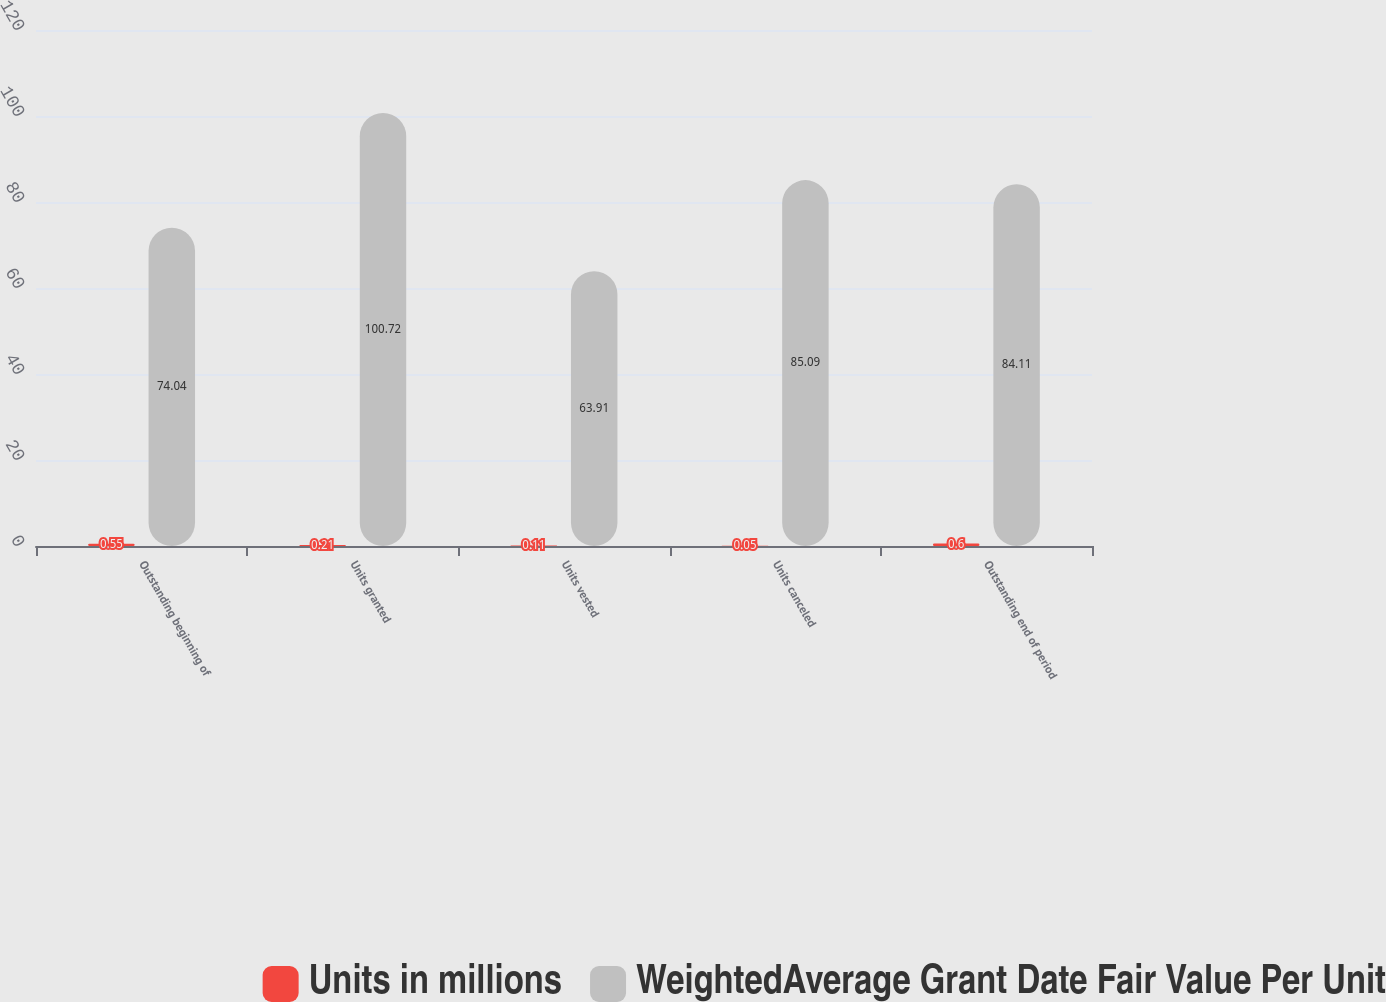Convert chart. <chart><loc_0><loc_0><loc_500><loc_500><stacked_bar_chart><ecel><fcel>Outstanding beginning of<fcel>Units granted<fcel>Units vested<fcel>Units canceled<fcel>Outstanding end of period<nl><fcel>Units in millions<fcel>0.55<fcel>0.21<fcel>0.11<fcel>0.05<fcel>0.6<nl><fcel>WeightedAverage Grant Date Fair Value Per Unit<fcel>74.04<fcel>100.72<fcel>63.91<fcel>85.09<fcel>84.11<nl></chart> 